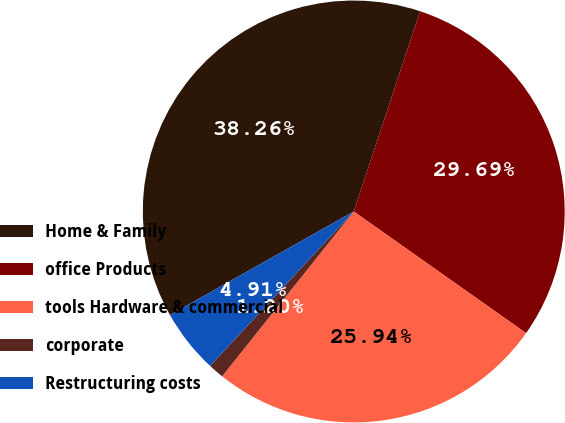<chart> <loc_0><loc_0><loc_500><loc_500><pie_chart><fcel>Home & Family<fcel>office Products<fcel>tools Hardware & commercial<fcel>corporate<fcel>Restructuring costs<nl><fcel>38.26%<fcel>29.69%<fcel>25.94%<fcel>1.2%<fcel>4.91%<nl></chart> 